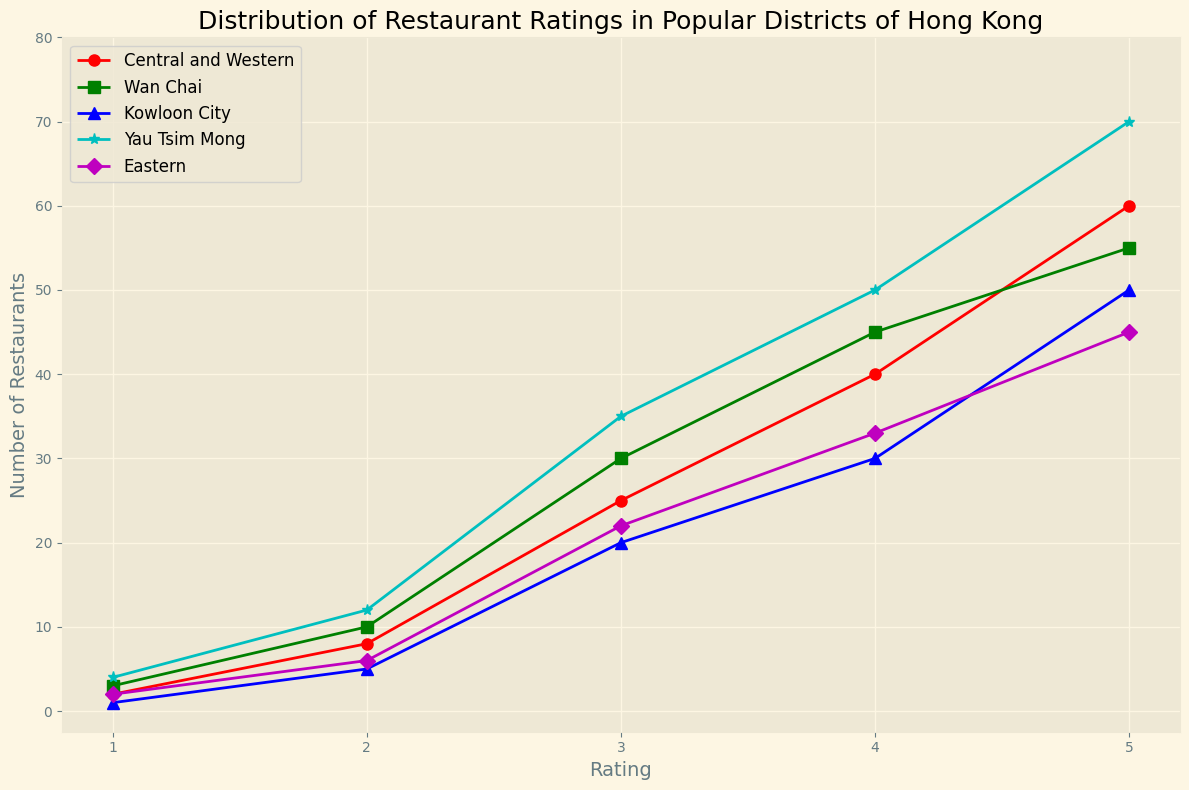What is the total number of restaurants in Central and Western with a rating of 4 or higher? First, identify the number of restaurants in Central and Western with a rating of 4 and 5. From the data, there are 40 restaurants with a rating of 4 and 60 restaurants with a rating of 5. Sum these numbers: 40 + 60 = 100
Answer: 100 Which district has the highest number of restaurants with a rating of 5? Check the data for the number of restaurants with a rating of 5 in each district. Central and Western has 60, Wan Chai has 55, Kowloon City has 50, Yau Tsim Mong has 70, and Eastern has 45. The highest number is in Yau Tsim Mong with 70 restaurants
Answer: Yau Tsim Mong Comparing districts, which one has more restaurants with a rating of 3, Wan Chai or Kowloon City? Find the number of restaurants with a rating of 3 in Wan Chai and Kowloon City. Wan Chai has 30, and Kowloon City has 20. Therefore, Wan Chai has more
Answer: Wan Chai What is the average number of restaurants in Eastern across all ratings? Sum the number of restaurants in Eastern for each rating (2 + 6 + 22 + 33 + 45) to get 108. There are 5 ratings, so divide 108 by 5. 108 / 5 = 21.6
Answer: 21.6 Which district has more restaurants with a rating of 1, Central and Western or Yau Tsim Mong? Check the number of restaurants with a rating of 1 in both districts. Central and Western has 2, and Yau Tsim Mong has 4. Therefore, Yau Tsim Mong has more
Answer: Yau Tsim Mong Which district shows the most balanced distribution of restaurant ratings? The most balanced distribution means the number of restaurants across ratings is relatively even. From the data, East seems most balanced with counts close among different ratings: 2 (1), 6 (2), 22 (3), 33 (4), 45 (5)
Answer: Eastern If combining all districts, what is the total number of restaurants with a rating of 2? Sum the number of restaurants with a rating of 2 across all districts: Central and Western (8), Wan Chai (10), Kowloon City (5), Yau Tsim Mong (12), Eastern (6). Total: 8 + 10 + 5 + 12 + 6 = 41
Answer: 41 